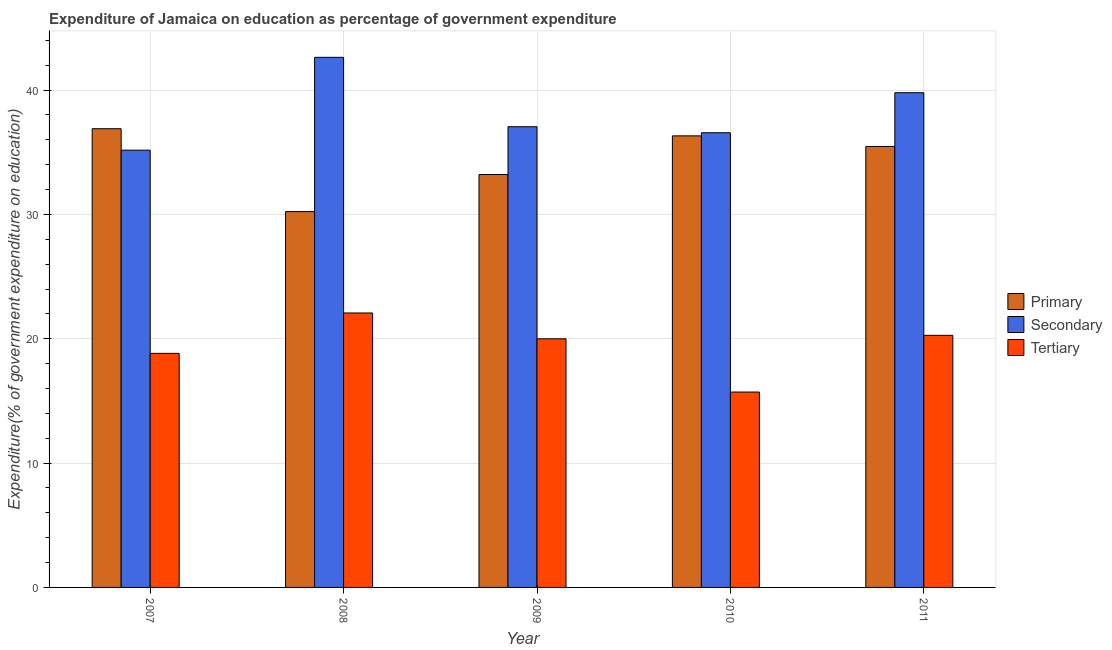How many groups of bars are there?
Make the answer very short. 5. What is the label of the 5th group of bars from the left?
Offer a very short reply. 2011. In how many cases, is the number of bars for a given year not equal to the number of legend labels?
Give a very brief answer. 0. What is the expenditure on secondary education in 2011?
Offer a very short reply. 39.79. Across all years, what is the maximum expenditure on primary education?
Offer a terse response. 36.89. Across all years, what is the minimum expenditure on tertiary education?
Your response must be concise. 15.71. In which year was the expenditure on primary education minimum?
Make the answer very short. 2008. What is the total expenditure on primary education in the graph?
Ensure brevity in your answer.  172.11. What is the difference between the expenditure on tertiary education in 2009 and that in 2010?
Ensure brevity in your answer.  4.28. What is the difference between the expenditure on tertiary education in 2007 and the expenditure on primary education in 2011?
Offer a very short reply. -1.45. What is the average expenditure on secondary education per year?
Provide a succinct answer. 38.24. In the year 2008, what is the difference between the expenditure on primary education and expenditure on tertiary education?
Offer a terse response. 0. In how many years, is the expenditure on tertiary education greater than 36 %?
Offer a very short reply. 0. What is the ratio of the expenditure on tertiary education in 2007 to that in 2010?
Ensure brevity in your answer.  1.2. Is the expenditure on tertiary education in 2007 less than that in 2010?
Provide a succinct answer. No. Is the difference between the expenditure on primary education in 2007 and 2008 greater than the difference between the expenditure on secondary education in 2007 and 2008?
Provide a short and direct response. No. What is the difference between the highest and the second highest expenditure on primary education?
Your answer should be compact. 0.58. What is the difference between the highest and the lowest expenditure on secondary education?
Make the answer very short. 7.47. In how many years, is the expenditure on tertiary education greater than the average expenditure on tertiary education taken over all years?
Offer a terse response. 3. Is the sum of the expenditure on secondary education in 2007 and 2010 greater than the maximum expenditure on tertiary education across all years?
Your answer should be compact. Yes. What does the 3rd bar from the left in 2007 represents?
Provide a succinct answer. Tertiary. What does the 1st bar from the right in 2007 represents?
Your answer should be compact. Tertiary. How many bars are there?
Make the answer very short. 15. Does the graph contain grids?
Ensure brevity in your answer.  Yes. Where does the legend appear in the graph?
Make the answer very short. Center right. How are the legend labels stacked?
Provide a short and direct response. Vertical. What is the title of the graph?
Your response must be concise. Expenditure of Jamaica on education as percentage of government expenditure. What is the label or title of the X-axis?
Offer a very short reply. Year. What is the label or title of the Y-axis?
Keep it short and to the point. Expenditure(% of government expenditure on education). What is the Expenditure(% of government expenditure on education) in Primary in 2007?
Keep it short and to the point. 36.89. What is the Expenditure(% of government expenditure on education) in Secondary in 2007?
Your answer should be compact. 35.17. What is the Expenditure(% of government expenditure on education) in Tertiary in 2007?
Your response must be concise. 18.82. What is the Expenditure(% of government expenditure on education) in Primary in 2008?
Your response must be concise. 30.23. What is the Expenditure(% of government expenditure on education) of Secondary in 2008?
Ensure brevity in your answer.  42.63. What is the Expenditure(% of government expenditure on education) of Tertiary in 2008?
Your response must be concise. 22.07. What is the Expenditure(% of government expenditure on education) in Primary in 2009?
Your response must be concise. 33.21. What is the Expenditure(% of government expenditure on education) of Secondary in 2009?
Keep it short and to the point. 37.05. What is the Expenditure(% of government expenditure on education) in Tertiary in 2009?
Offer a very short reply. 20. What is the Expenditure(% of government expenditure on education) in Primary in 2010?
Your answer should be very brief. 36.32. What is the Expenditure(% of government expenditure on education) of Secondary in 2010?
Offer a very short reply. 36.57. What is the Expenditure(% of government expenditure on education) in Tertiary in 2010?
Give a very brief answer. 15.71. What is the Expenditure(% of government expenditure on education) in Primary in 2011?
Keep it short and to the point. 35.46. What is the Expenditure(% of government expenditure on education) of Secondary in 2011?
Your answer should be compact. 39.79. What is the Expenditure(% of government expenditure on education) in Tertiary in 2011?
Your answer should be very brief. 20.27. Across all years, what is the maximum Expenditure(% of government expenditure on education) in Primary?
Keep it short and to the point. 36.89. Across all years, what is the maximum Expenditure(% of government expenditure on education) of Secondary?
Make the answer very short. 42.63. Across all years, what is the maximum Expenditure(% of government expenditure on education) of Tertiary?
Keep it short and to the point. 22.07. Across all years, what is the minimum Expenditure(% of government expenditure on education) in Primary?
Keep it short and to the point. 30.23. Across all years, what is the minimum Expenditure(% of government expenditure on education) of Secondary?
Your answer should be very brief. 35.17. Across all years, what is the minimum Expenditure(% of government expenditure on education) in Tertiary?
Offer a very short reply. 15.71. What is the total Expenditure(% of government expenditure on education) in Primary in the graph?
Ensure brevity in your answer.  172.11. What is the total Expenditure(% of government expenditure on education) of Secondary in the graph?
Give a very brief answer. 191.2. What is the total Expenditure(% of government expenditure on education) in Tertiary in the graph?
Provide a succinct answer. 96.88. What is the difference between the Expenditure(% of government expenditure on education) of Primary in 2007 and that in 2008?
Provide a succinct answer. 6.67. What is the difference between the Expenditure(% of government expenditure on education) in Secondary in 2007 and that in 2008?
Ensure brevity in your answer.  -7.47. What is the difference between the Expenditure(% of government expenditure on education) of Tertiary in 2007 and that in 2008?
Provide a succinct answer. -3.25. What is the difference between the Expenditure(% of government expenditure on education) in Primary in 2007 and that in 2009?
Ensure brevity in your answer.  3.69. What is the difference between the Expenditure(% of government expenditure on education) in Secondary in 2007 and that in 2009?
Ensure brevity in your answer.  -1.89. What is the difference between the Expenditure(% of government expenditure on education) in Tertiary in 2007 and that in 2009?
Offer a terse response. -1.17. What is the difference between the Expenditure(% of government expenditure on education) of Primary in 2007 and that in 2010?
Your answer should be compact. 0.58. What is the difference between the Expenditure(% of government expenditure on education) of Secondary in 2007 and that in 2010?
Your answer should be very brief. -1.4. What is the difference between the Expenditure(% of government expenditure on education) in Tertiary in 2007 and that in 2010?
Provide a succinct answer. 3.11. What is the difference between the Expenditure(% of government expenditure on education) of Primary in 2007 and that in 2011?
Your answer should be compact. 1.43. What is the difference between the Expenditure(% of government expenditure on education) in Secondary in 2007 and that in 2011?
Give a very brief answer. -4.62. What is the difference between the Expenditure(% of government expenditure on education) in Tertiary in 2007 and that in 2011?
Provide a succinct answer. -1.45. What is the difference between the Expenditure(% of government expenditure on education) in Primary in 2008 and that in 2009?
Provide a succinct answer. -2.98. What is the difference between the Expenditure(% of government expenditure on education) of Secondary in 2008 and that in 2009?
Offer a terse response. 5.58. What is the difference between the Expenditure(% of government expenditure on education) in Tertiary in 2008 and that in 2009?
Make the answer very short. 2.08. What is the difference between the Expenditure(% of government expenditure on education) in Primary in 2008 and that in 2010?
Your answer should be very brief. -6.09. What is the difference between the Expenditure(% of government expenditure on education) of Secondary in 2008 and that in 2010?
Ensure brevity in your answer.  6.06. What is the difference between the Expenditure(% of government expenditure on education) in Tertiary in 2008 and that in 2010?
Give a very brief answer. 6.36. What is the difference between the Expenditure(% of government expenditure on education) of Primary in 2008 and that in 2011?
Your response must be concise. -5.24. What is the difference between the Expenditure(% of government expenditure on education) in Secondary in 2008 and that in 2011?
Ensure brevity in your answer.  2.85. What is the difference between the Expenditure(% of government expenditure on education) in Tertiary in 2008 and that in 2011?
Make the answer very short. 1.8. What is the difference between the Expenditure(% of government expenditure on education) of Primary in 2009 and that in 2010?
Provide a succinct answer. -3.11. What is the difference between the Expenditure(% of government expenditure on education) of Secondary in 2009 and that in 2010?
Offer a very short reply. 0.48. What is the difference between the Expenditure(% of government expenditure on education) of Tertiary in 2009 and that in 2010?
Offer a terse response. 4.28. What is the difference between the Expenditure(% of government expenditure on education) in Primary in 2009 and that in 2011?
Keep it short and to the point. -2.26. What is the difference between the Expenditure(% of government expenditure on education) of Secondary in 2009 and that in 2011?
Provide a short and direct response. -2.73. What is the difference between the Expenditure(% of government expenditure on education) of Tertiary in 2009 and that in 2011?
Offer a very short reply. -0.28. What is the difference between the Expenditure(% of government expenditure on education) in Primary in 2010 and that in 2011?
Offer a terse response. 0.85. What is the difference between the Expenditure(% of government expenditure on education) in Secondary in 2010 and that in 2011?
Make the answer very short. -3.22. What is the difference between the Expenditure(% of government expenditure on education) in Tertiary in 2010 and that in 2011?
Your response must be concise. -4.56. What is the difference between the Expenditure(% of government expenditure on education) in Primary in 2007 and the Expenditure(% of government expenditure on education) in Secondary in 2008?
Keep it short and to the point. -5.74. What is the difference between the Expenditure(% of government expenditure on education) in Primary in 2007 and the Expenditure(% of government expenditure on education) in Tertiary in 2008?
Your answer should be very brief. 14.82. What is the difference between the Expenditure(% of government expenditure on education) of Secondary in 2007 and the Expenditure(% of government expenditure on education) of Tertiary in 2008?
Your answer should be compact. 13.09. What is the difference between the Expenditure(% of government expenditure on education) in Primary in 2007 and the Expenditure(% of government expenditure on education) in Secondary in 2009?
Ensure brevity in your answer.  -0.16. What is the difference between the Expenditure(% of government expenditure on education) in Primary in 2007 and the Expenditure(% of government expenditure on education) in Tertiary in 2009?
Give a very brief answer. 16.9. What is the difference between the Expenditure(% of government expenditure on education) in Secondary in 2007 and the Expenditure(% of government expenditure on education) in Tertiary in 2009?
Provide a succinct answer. 15.17. What is the difference between the Expenditure(% of government expenditure on education) in Primary in 2007 and the Expenditure(% of government expenditure on education) in Secondary in 2010?
Give a very brief answer. 0.32. What is the difference between the Expenditure(% of government expenditure on education) of Primary in 2007 and the Expenditure(% of government expenditure on education) of Tertiary in 2010?
Your response must be concise. 21.18. What is the difference between the Expenditure(% of government expenditure on education) of Secondary in 2007 and the Expenditure(% of government expenditure on education) of Tertiary in 2010?
Give a very brief answer. 19.45. What is the difference between the Expenditure(% of government expenditure on education) in Primary in 2007 and the Expenditure(% of government expenditure on education) in Secondary in 2011?
Provide a succinct answer. -2.89. What is the difference between the Expenditure(% of government expenditure on education) of Primary in 2007 and the Expenditure(% of government expenditure on education) of Tertiary in 2011?
Your answer should be very brief. 16.62. What is the difference between the Expenditure(% of government expenditure on education) of Secondary in 2007 and the Expenditure(% of government expenditure on education) of Tertiary in 2011?
Your answer should be very brief. 14.89. What is the difference between the Expenditure(% of government expenditure on education) of Primary in 2008 and the Expenditure(% of government expenditure on education) of Secondary in 2009?
Your response must be concise. -6.83. What is the difference between the Expenditure(% of government expenditure on education) in Primary in 2008 and the Expenditure(% of government expenditure on education) in Tertiary in 2009?
Your answer should be compact. 10.23. What is the difference between the Expenditure(% of government expenditure on education) of Secondary in 2008 and the Expenditure(% of government expenditure on education) of Tertiary in 2009?
Your answer should be very brief. 22.64. What is the difference between the Expenditure(% of government expenditure on education) in Primary in 2008 and the Expenditure(% of government expenditure on education) in Secondary in 2010?
Provide a short and direct response. -6.34. What is the difference between the Expenditure(% of government expenditure on education) in Primary in 2008 and the Expenditure(% of government expenditure on education) in Tertiary in 2010?
Provide a short and direct response. 14.51. What is the difference between the Expenditure(% of government expenditure on education) in Secondary in 2008 and the Expenditure(% of government expenditure on education) in Tertiary in 2010?
Your answer should be compact. 26.92. What is the difference between the Expenditure(% of government expenditure on education) in Primary in 2008 and the Expenditure(% of government expenditure on education) in Secondary in 2011?
Your answer should be compact. -9.56. What is the difference between the Expenditure(% of government expenditure on education) of Primary in 2008 and the Expenditure(% of government expenditure on education) of Tertiary in 2011?
Keep it short and to the point. 9.95. What is the difference between the Expenditure(% of government expenditure on education) in Secondary in 2008 and the Expenditure(% of government expenditure on education) in Tertiary in 2011?
Provide a short and direct response. 22.36. What is the difference between the Expenditure(% of government expenditure on education) of Primary in 2009 and the Expenditure(% of government expenditure on education) of Secondary in 2010?
Offer a very short reply. -3.36. What is the difference between the Expenditure(% of government expenditure on education) in Primary in 2009 and the Expenditure(% of government expenditure on education) in Tertiary in 2010?
Provide a short and direct response. 17.49. What is the difference between the Expenditure(% of government expenditure on education) of Secondary in 2009 and the Expenditure(% of government expenditure on education) of Tertiary in 2010?
Keep it short and to the point. 21.34. What is the difference between the Expenditure(% of government expenditure on education) in Primary in 2009 and the Expenditure(% of government expenditure on education) in Secondary in 2011?
Your answer should be very brief. -6.58. What is the difference between the Expenditure(% of government expenditure on education) of Primary in 2009 and the Expenditure(% of government expenditure on education) of Tertiary in 2011?
Make the answer very short. 12.93. What is the difference between the Expenditure(% of government expenditure on education) of Secondary in 2009 and the Expenditure(% of government expenditure on education) of Tertiary in 2011?
Give a very brief answer. 16.78. What is the difference between the Expenditure(% of government expenditure on education) in Primary in 2010 and the Expenditure(% of government expenditure on education) in Secondary in 2011?
Ensure brevity in your answer.  -3.47. What is the difference between the Expenditure(% of government expenditure on education) of Primary in 2010 and the Expenditure(% of government expenditure on education) of Tertiary in 2011?
Offer a very short reply. 16.04. What is the difference between the Expenditure(% of government expenditure on education) in Secondary in 2010 and the Expenditure(% of government expenditure on education) in Tertiary in 2011?
Provide a succinct answer. 16.29. What is the average Expenditure(% of government expenditure on education) in Primary per year?
Your answer should be very brief. 34.42. What is the average Expenditure(% of government expenditure on education) in Secondary per year?
Your response must be concise. 38.24. What is the average Expenditure(% of government expenditure on education) in Tertiary per year?
Offer a very short reply. 19.38. In the year 2007, what is the difference between the Expenditure(% of government expenditure on education) in Primary and Expenditure(% of government expenditure on education) in Secondary?
Give a very brief answer. 1.73. In the year 2007, what is the difference between the Expenditure(% of government expenditure on education) in Primary and Expenditure(% of government expenditure on education) in Tertiary?
Provide a succinct answer. 18.07. In the year 2007, what is the difference between the Expenditure(% of government expenditure on education) of Secondary and Expenditure(% of government expenditure on education) of Tertiary?
Your response must be concise. 16.34. In the year 2008, what is the difference between the Expenditure(% of government expenditure on education) of Primary and Expenditure(% of government expenditure on education) of Secondary?
Provide a succinct answer. -12.41. In the year 2008, what is the difference between the Expenditure(% of government expenditure on education) of Primary and Expenditure(% of government expenditure on education) of Tertiary?
Provide a succinct answer. 8.15. In the year 2008, what is the difference between the Expenditure(% of government expenditure on education) of Secondary and Expenditure(% of government expenditure on education) of Tertiary?
Offer a terse response. 20.56. In the year 2009, what is the difference between the Expenditure(% of government expenditure on education) in Primary and Expenditure(% of government expenditure on education) in Secondary?
Provide a succinct answer. -3.85. In the year 2009, what is the difference between the Expenditure(% of government expenditure on education) in Primary and Expenditure(% of government expenditure on education) in Tertiary?
Keep it short and to the point. 13.21. In the year 2009, what is the difference between the Expenditure(% of government expenditure on education) in Secondary and Expenditure(% of government expenditure on education) in Tertiary?
Keep it short and to the point. 17.06. In the year 2010, what is the difference between the Expenditure(% of government expenditure on education) of Primary and Expenditure(% of government expenditure on education) of Secondary?
Make the answer very short. -0.25. In the year 2010, what is the difference between the Expenditure(% of government expenditure on education) in Primary and Expenditure(% of government expenditure on education) in Tertiary?
Your answer should be compact. 20.6. In the year 2010, what is the difference between the Expenditure(% of government expenditure on education) in Secondary and Expenditure(% of government expenditure on education) in Tertiary?
Provide a succinct answer. 20.86. In the year 2011, what is the difference between the Expenditure(% of government expenditure on education) in Primary and Expenditure(% of government expenditure on education) in Secondary?
Give a very brief answer. -4.32. In the year 2011, what is the difference between the Expenditure(% of government expenditure on education) of Primary and Expenditure(% of government expenditure on education) of Tertiary?
Keep it short and to the point. 15.19. In the year 2011, what is the difference between the Expenditure(% of government expenditure on education) in Secondary and Expenditure(% of government expenditure on education) in Tertiary?
Offer a terse response. 19.51. What is the ratio of the Expenditure(% of government expenditure on education) in Primary in 2007 to that in 2008?
Your response must be concise. 1.22. What is the ratio of the Expenditure(% of government expenditure on education) in Secondary in 2007 to that in 2008?
Make the answer very short. 0.82. What is the ratio of the Expenditure(% of government expenditure on education) of Tertiary in 2007 to that in 2008?
Offer a very short reply. 0.85. What is the ratio of the Expenditure(% of government expenditure on education) in Primary in 2007 to that in 2009?
Provide a succinct answer. 1.11. What is the ratio of the Expenditure(% of government expenditure on education) in Secondary in 2007 to that in 2009?
Your response must be concise. 0.95. What is the ratio of the Expenditure(% of government expenditure on education) of Tertiary in 2007 to that in 2009?
Give a very brief answer. 0.94. What is the ratio of the Expenditure(% of government expenditure on education) of Primary in 2007 to that in 2010?
Your response must be concise. 1.02. What is the ratio of the Expenditure(% of government expenditure on education) of Secondary in 2007 to that in 2010?
Your answer should be very brief. 0.96. What is the ratio of the Expenditure(% of government expenditure on education) of Tertiary in 2007 to that in 2010?
Give a very brief answer. 1.2. What is the ratio of the Expenditure(% of government expenditure on education) in Primary in 2007 to that in 2011?
Give a very brief answer. 1.04. What is the ratio of the Expenditure(% of government expenditure on education) of Secondary in 2007 to that in 2011?
Your response must be concise. 0.88. What is the ratio of the Expenditure(% of government expenditure on education) in Tertiary in 2007 to that in 2011?
Provide a succinct answer. 0.93. What is the ratio of the Expenditure(% of government expenditure on education) in Primary in 2008 to that in 2009?
Your response must be concise. 0.91. What is the ratio of the Expenditure(% of government expenditure on education) of Secondary in 2008 to that in 2009?
Your response must be concise. 1.15. What is the ratio of the Expenditure(% of government expenditure on education) in Tertiary in 2008 to that in 2009?
Keep it short and to the point. 1.1. What is the ratio of the Expenditure(% of government expenditure on education) in Primary in 2008 to that in 2010?
Keep it short and to the point. 0.83. What is the ratio of the Expenditure(% of government expenditure on education) of Secondary in 2008 to that in 2010?
Your answer should be compact. 1.17. What is the ratio of the Expenditure(% of government expenditure on education) of Tertiary in 2008 to that in 2010?
Your answer should be very brief. 1.4. What is the ratio of the Expenditure(% of government expenditure on education) in Primary in 2008 to that in 2011?
Your response must be concise. 0.85. What is the ratio of the Expenditure(% of government expenditure on education) of Secondary in 2008 to that in 2011?
Offer a terse response. 1.07. What is the ratio of the Expenditure(% of government expenditure on education) of Tertiary in 2008 to that in 2011?
Provide a short and direct response. 1.09. What is the ratio of the Expenditure(% of government expenditure on education) in Primary in 2009 to that in 2010?
Your response must be concise. 0.91. What is the ratio of the Expenditure(% of government expenditure on education) of Secondary in 2009 to that in 2010?
Give a very brief answer. 1.01. What is the ratio of the Expenditure(% of government expenditure on education) of Tertiary in 2009 to that in 2010?
Keep it short and to the point. 1.27. What is the ratio of the Expenditure(% of government expenditure on education) in Primary in 2009 to that in 2011?
Give a very brief answer. 0.94. What is the ratio of the Expenditure(% of government expenditure on education) in Secondary in 2009 to that in 2011?
Offer a very short reply. 0.93. What is the ratio of the Expenditure(% of government expenditure on education) of Tertiary in 2009 to that in 2011?
Ensure brevity in your answer.  0.99. What is the ratio of the Expenditure(% of government expenditure on education) of Primary in 2010 to that in 2011?
Ensure brevity in your answer.  1.02. What is the ratio of the Expenditure(% of government expenditure on education) of Secondary in 2010 to that in 2011?
Make the answer very short. 0.92. What is the ratio of the Expenditure(% of government expenditure on education) of Tertiary in 2010 to that in 2011?
Provide a succinct answer. 0.78. What is the difference between the highest and the second highest Expenditure(% of government expenditure on education) of Primary?
Your answer should be compact. 0.58. What is the difference between the highest and the second highest Expenditure(% of government expenditure on education) in Secondary?
Your response must be concise. 2.85. What is the difference between the highest and the second highest Expenditure(% of government expenditure on education) of Tertiary?
Keep it short and to the point. 1.8. What is the difference between the highest and the lowest Expenditure(% of government expenditure on education) in Primary?
Give a very brief answer. 6.67. What is the difference between the highest and the lowest Expenditure(% of government expenditure on education) in Secondary?
Give a very brief answer. 7.47. What is the difference between the highest and the lowest Expenditure(% of government expenditure on education) of Tertiary?
Keep it short and to the point. 6.36. 